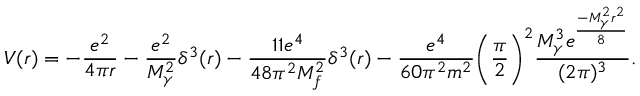Convert formula to latex. <formula><loc_0><loc_0><loc_500><loc_500>V ( r ) = - \frac { e ^ { 2 } } { 4 \pi r } - \frac { e ^ { 2 } } { M _ { \gamma } ^ { 2 } } \delta ^ { 3 } ( r ) - \frac { 1 1 e ^ { 4 } } { 4 8 \pi ^ { 2 } M _ { f } ^ { 2 } } \delta ^ { 3 } ( r ) - \frac { e ^ { 4 } } { 6 0 \pi ^ { 2 } m ^ { 2 } } \left ( \frac { \pi } { 2 } \right ) ^ { 2 } \frac { M _ { \gamma } ^ { 3 } e ^ { \frac { - M _ { \gamma } ^ { 2 } r ^ { 2 } } { 8 } } } { ( 2 \pi ) ^ { 3 } } .</formula> 